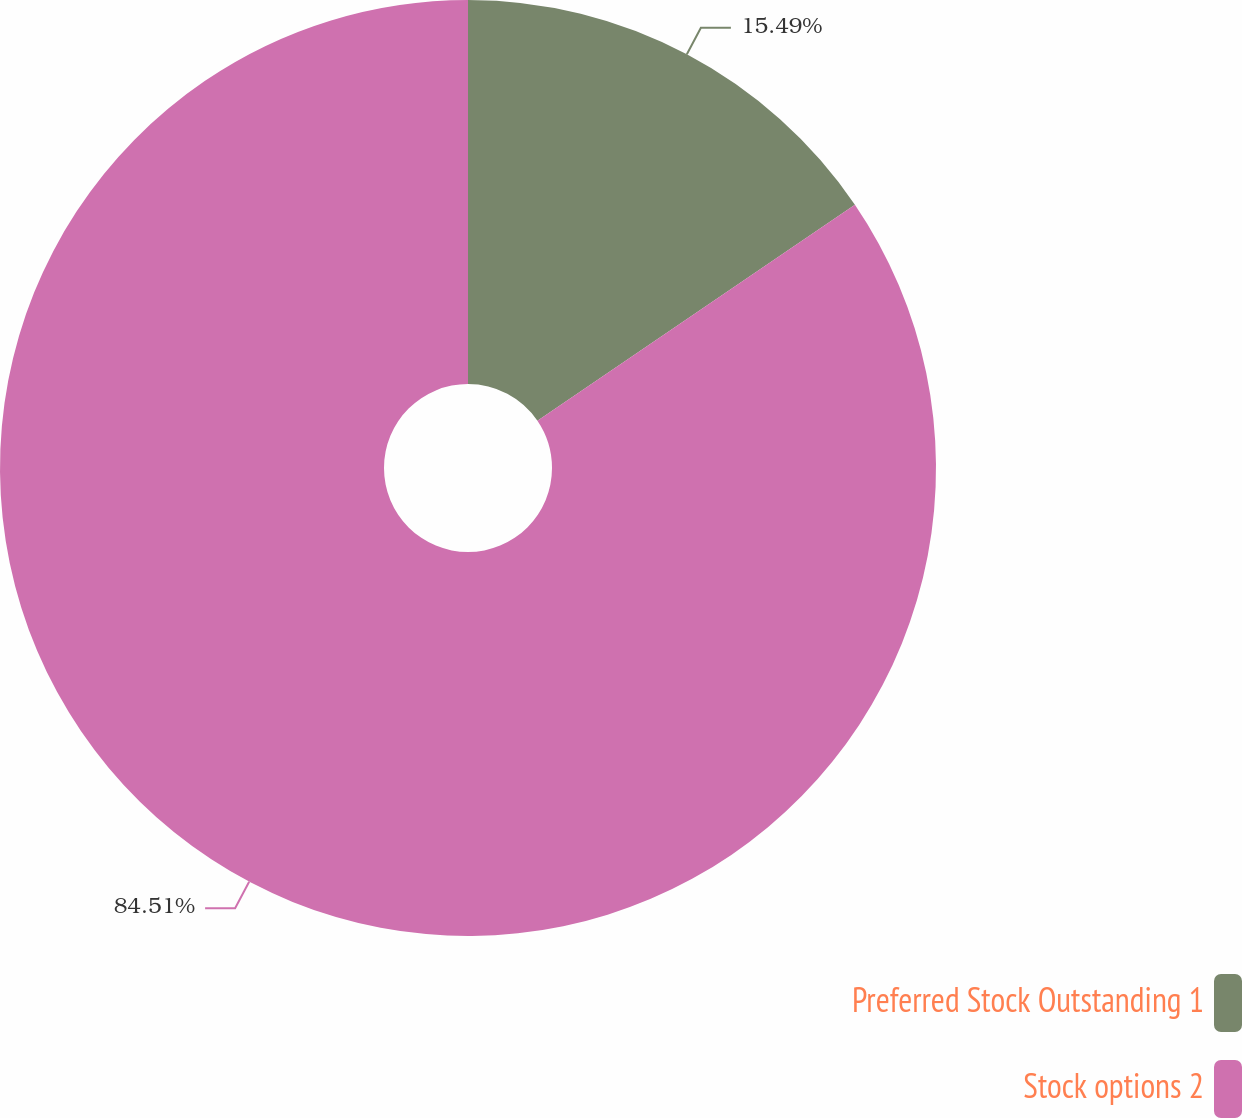Convert chart to OTSL. <chart><loc_0><loc_0><loc_500><loc_500><pie_chart><fcel>Preferred Stock Outstanding 1<fcel>Stock options 2<nl><fcel>15.49%<fcel>84.51%<nl></chart> 